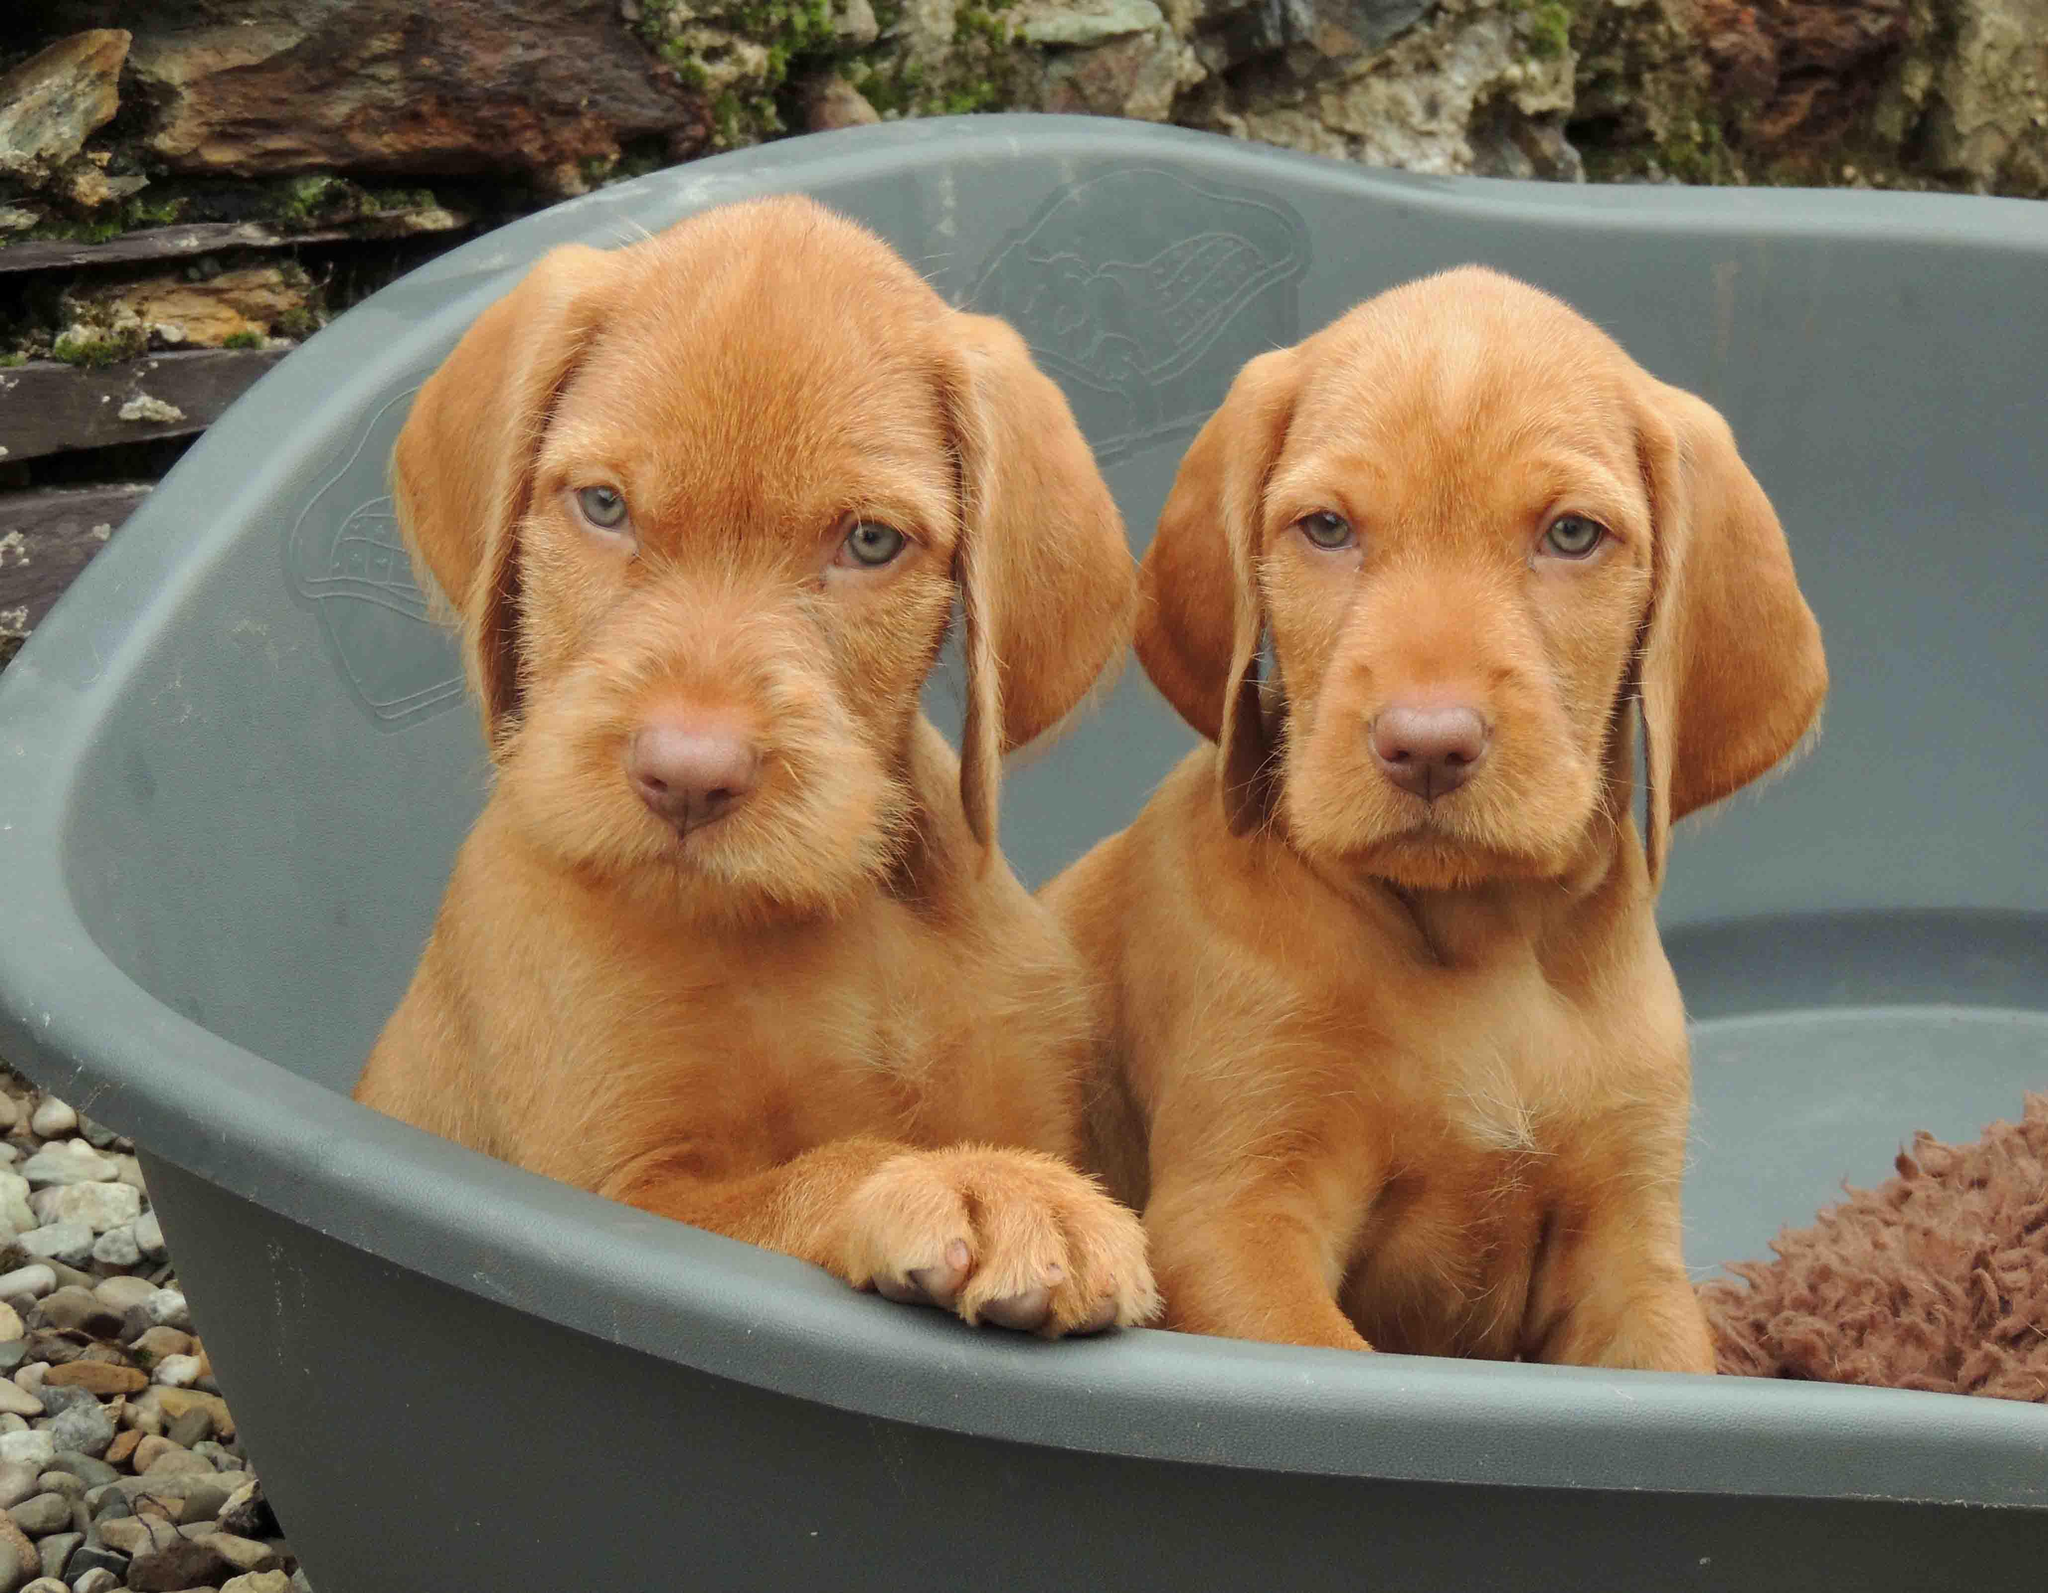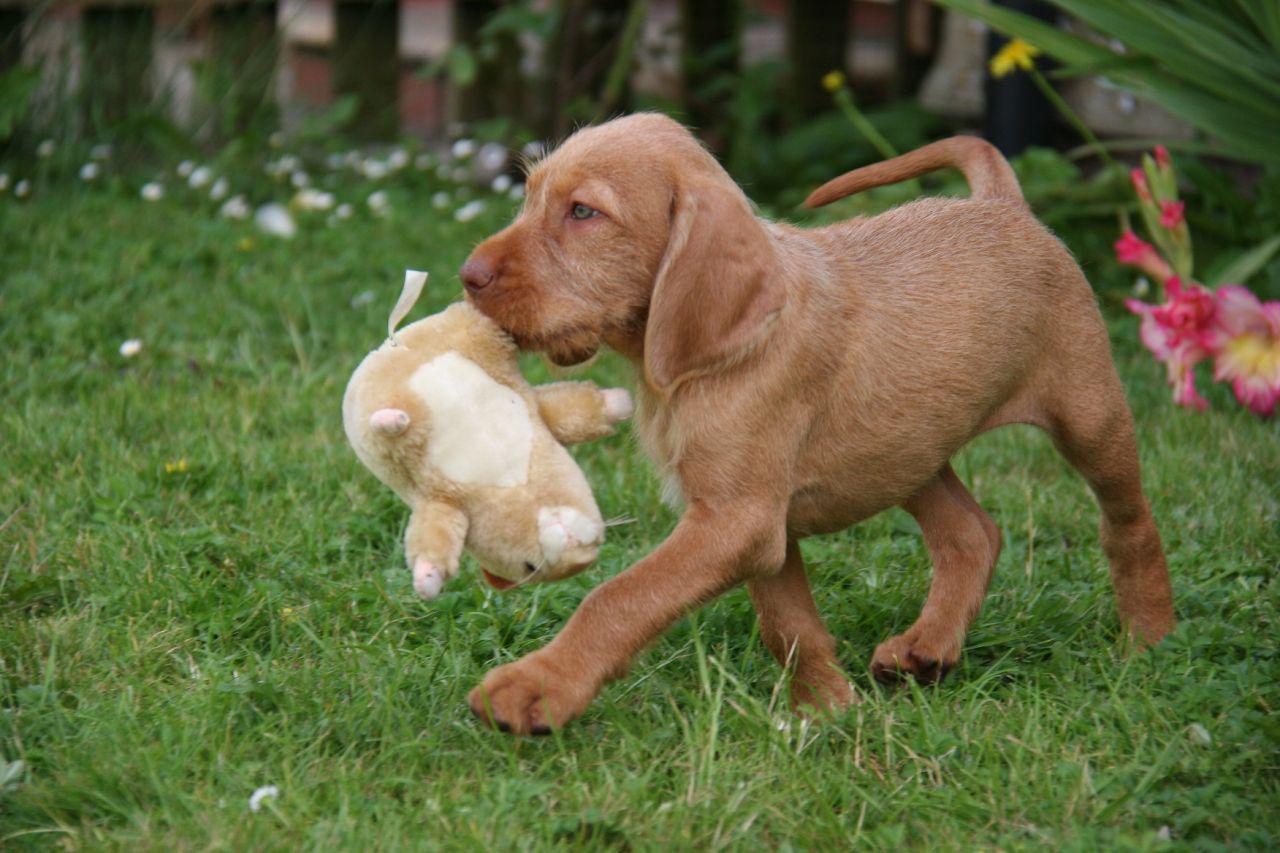The first image is the image on the left, the second image is the image on the right. Assess this claim about the two images: "The left image shows two look-alike dogs side-by-side, gazing in the same direction, and the right image shows one brown dog walking with an animal figure in its mouth.". Correct or not? Answer yes or no. Yes. The first image is the image on the left, the second image is the image on the right. Evaluate the accuracy of this statement regarding the images: "A dog walks through the grass as it carries something in its mouth.". Is it true? Answer yes or no. Yes. 